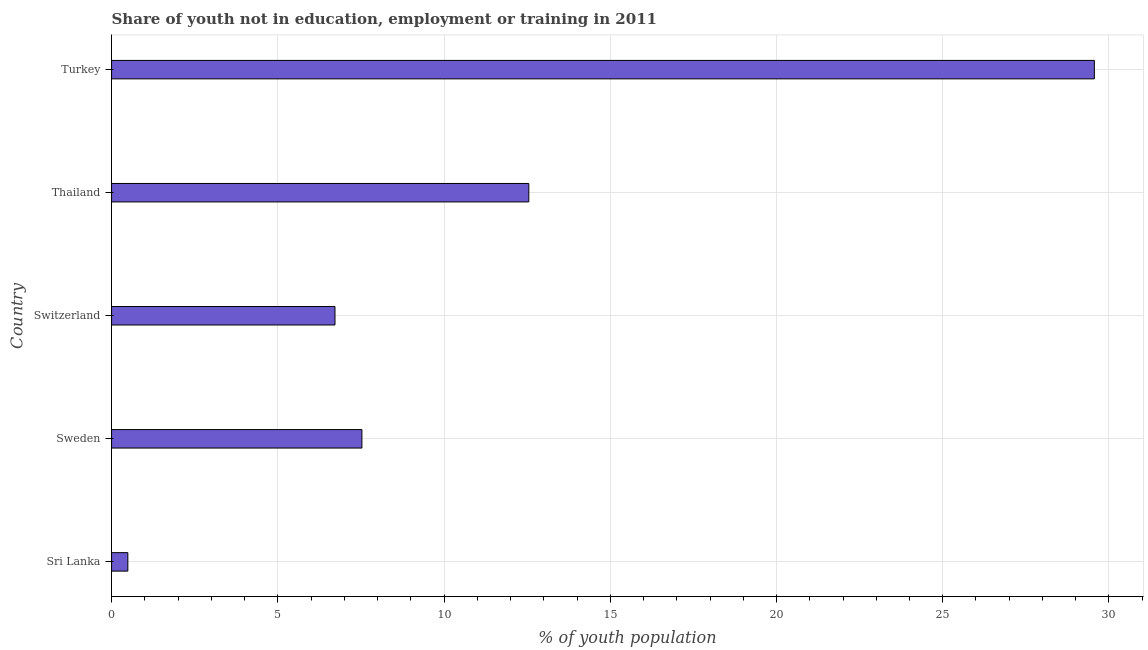What is the title of the graph?
Provide a short and direct response. Share of youth not in education, employment or training in 2011. What is the label or title of the X-axis?
Your answer should be compact. % of youth population. What is the label or title of the Y-axis?
Your answer should be compact. Country. What is the unemployed youth population in Turkey?
Offer a terse response. 29.56. Across all countries, what is the maximum unemployed youth population?
Offer a terse response. 29.56. Across all countries, what is the minimum unemployed youth population?
Offer a terse response. 0.49. In which country was the unemployed youth population minimum?
Keep it short and to the point. Sri Lanka. What is the sum of the unemployed youth population?
Offer a terse response. 56.85. What is the difference between the unemployed youth population in Sri Lanka and Switzerland?
Your answer should be compact. -6.23. What is the average unemployed youth population per country?
Provide a short and direct response. 11.37. What is the median unemployed youth population?
Offer a terse response. 7.53. What is the ratio of the unemployed youth population in Sri Lanka to that in Switzerland?
Give a very brief answer. 0.07. What is the difference between the highest and the second highest unemployed youth population?
Your answer should be compact. 17.01. What is the difference between the highest and the lowest unemployed youth population?
Ensure brevity in your answer.  29.07. How many countries are there in the graph?
Make the answer very short. 5. What is the difference between two consecutive major ticks on the X-axis?
Your answer should be very brief. 5. Are the values on the major ticks of X-axis written in scientific E-notation?
Keep it short and to the point. No. What is the % of youth population of Sri Lanka?
Provide a succinct answer. 0.49. What is the % of youth population of Sweden?
Offer a very short reply. 7.53. What is the % of youth population in Switzerland?
Your answer should be very brief. 6.72. What is the % of youth population in Thailand?
Your answer should be very brief. 12.55. What is the % of youth population in Turkey?
Your answer should be very brief. 29.56. What is the difference between the % of youth population in Sri Lanka and Sweden?
Offer a very short reply. -7.04. What is the difference between the % of youth population in Sri Lanka and Switzerland?
Your response must be concise. -6.23. What is the difference between the % of youth population in Sri Lanka and Thailand?
Ensure brevity in your answer.  -12.06. What is the difference between the % of youth population in Sri Lanka and Turkey?
Your answer should be compact. -29.07. What is the difference between the % of youth population in Sweden and Switzerland?
Provide a short and direct response. 0.81. What is the difference between the % of youth population in Sweden and Thailand?
Offer a terse response. -5.02. What is the difference between the % of youth population in Sweden and Turkey?
Ensure brevity in your answer.  -22.03. What is the difference between the % of youth population in Switzerland and Thailand?
Offer a very short reply. -5.83. What is the difference between the % of youth population in Switzerland and Turkey?
Provide a short and direct response. -22.84. What is the difference between the % of youth population in Thailand and Turkey?
Offer a very short reply. -17.01. What is the ratio of the % of youth population in Sri Lanka to that in Sweden?
Your response must be concise. 0.07. What is the ratio of the % of youth population in Sri Lanka to that in Switzerland?
Provide a succinct answer. 0.07. What is the ratio of the % of youth population in Sri Lanka to that in Thailand?
Your answer should be very brief. 0.04. What is the ratio of the % of youth population in Sri Lanka to that in Turkey?
Your answer should be very brief. 0.02. What is the ratio of the % of youth population in Sweden to that in Switzerland?
Give a very brief answer. 1.12. What is the ratio of the % of youth population in Sweden to that in Thailand?
Provide a short and direct response. 0.6. What is the ratio of the % of youth population in Sweden to that in Turkey?
Offer a terse response. 0.26. What is the ratio of the % of youth population in Switzerland to that in Thailand?
Provide a succinct answer. 0.54. What is the ratio of the % of youth population in Switzerland to that in Turkey?
Offer a terse response. 0.23. What is the ratio of the % of youth population in Thailand to that in Turkey?
Keep it short and to the point. 0.42. 